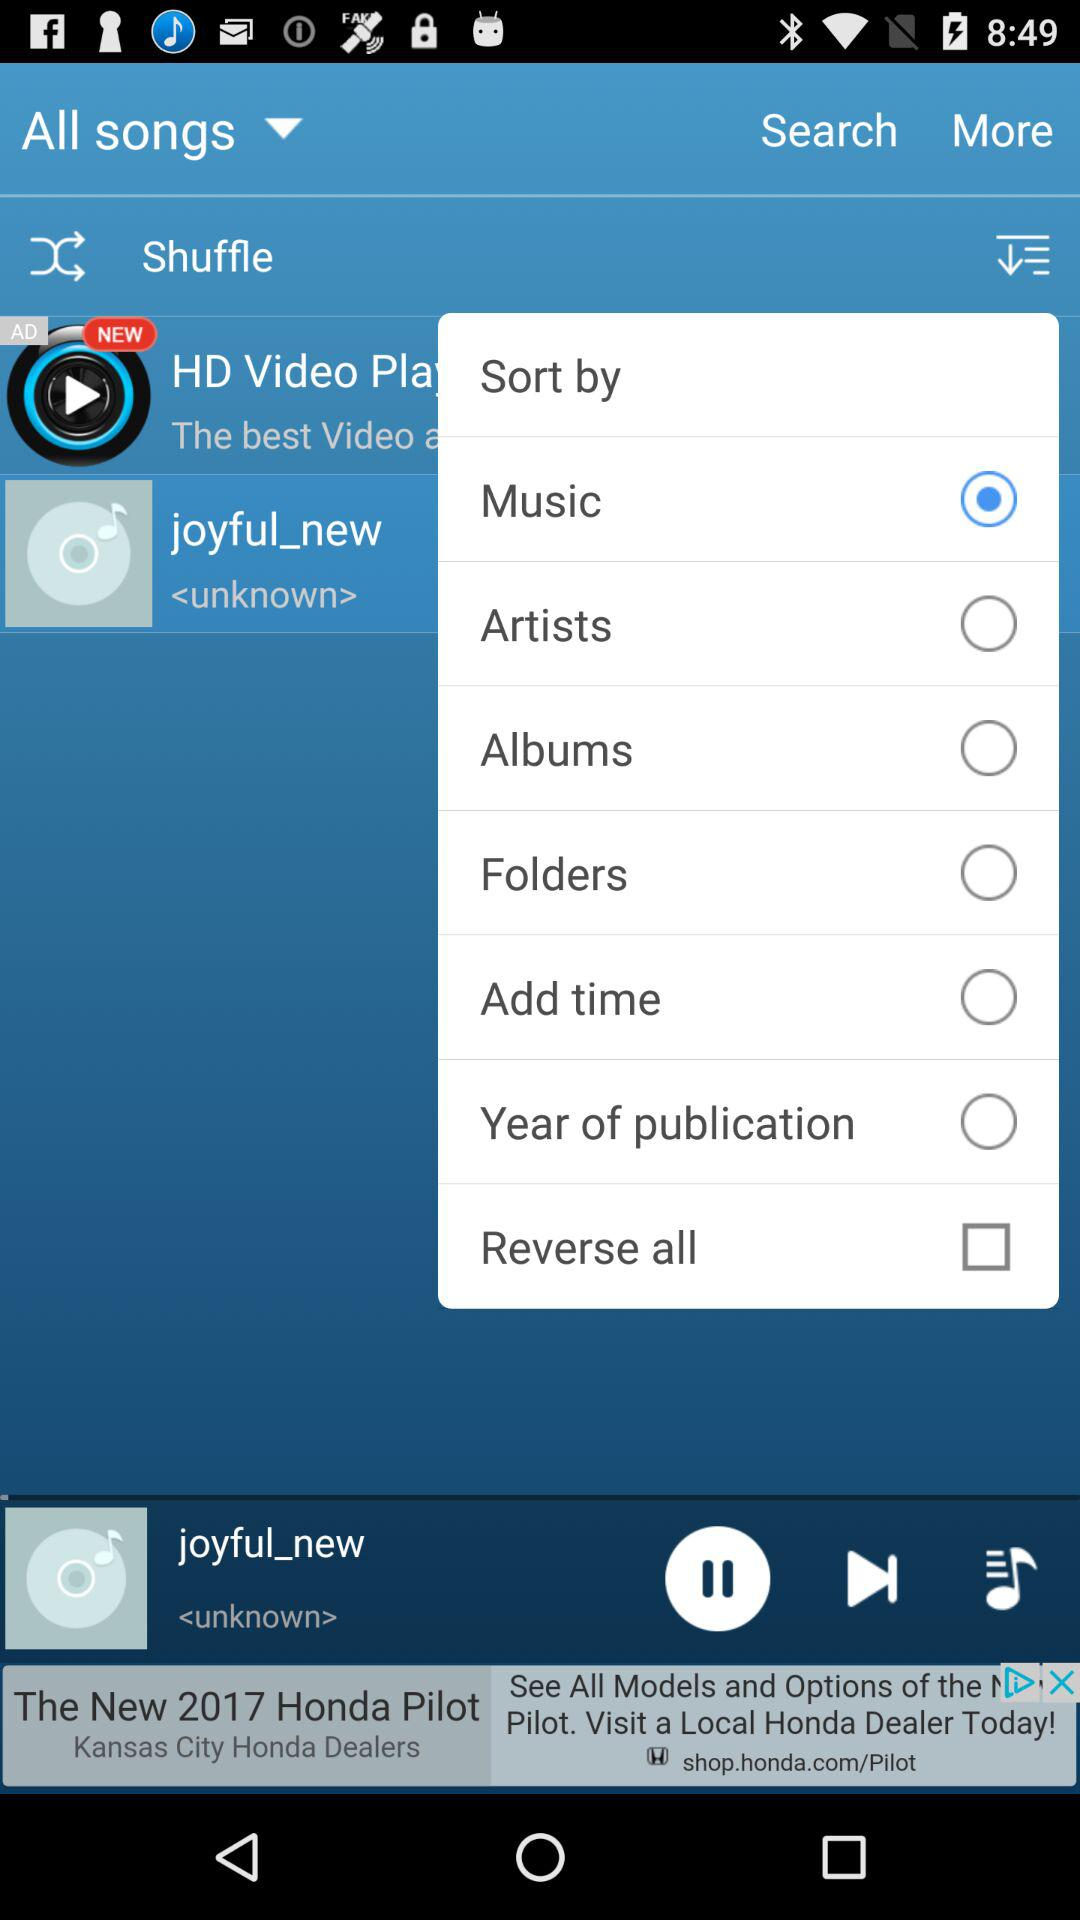Which song is currently playing? The currently playing song is "joyful_new". 